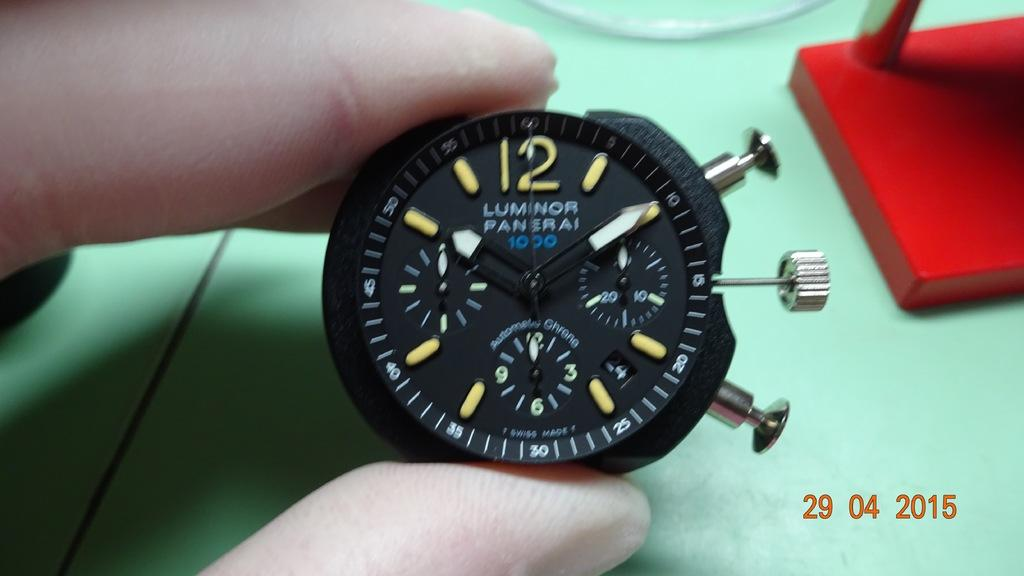<image>
Offer a succinct explanation of the picture presented. A person is holding a watch that says Luminor Panerai. 